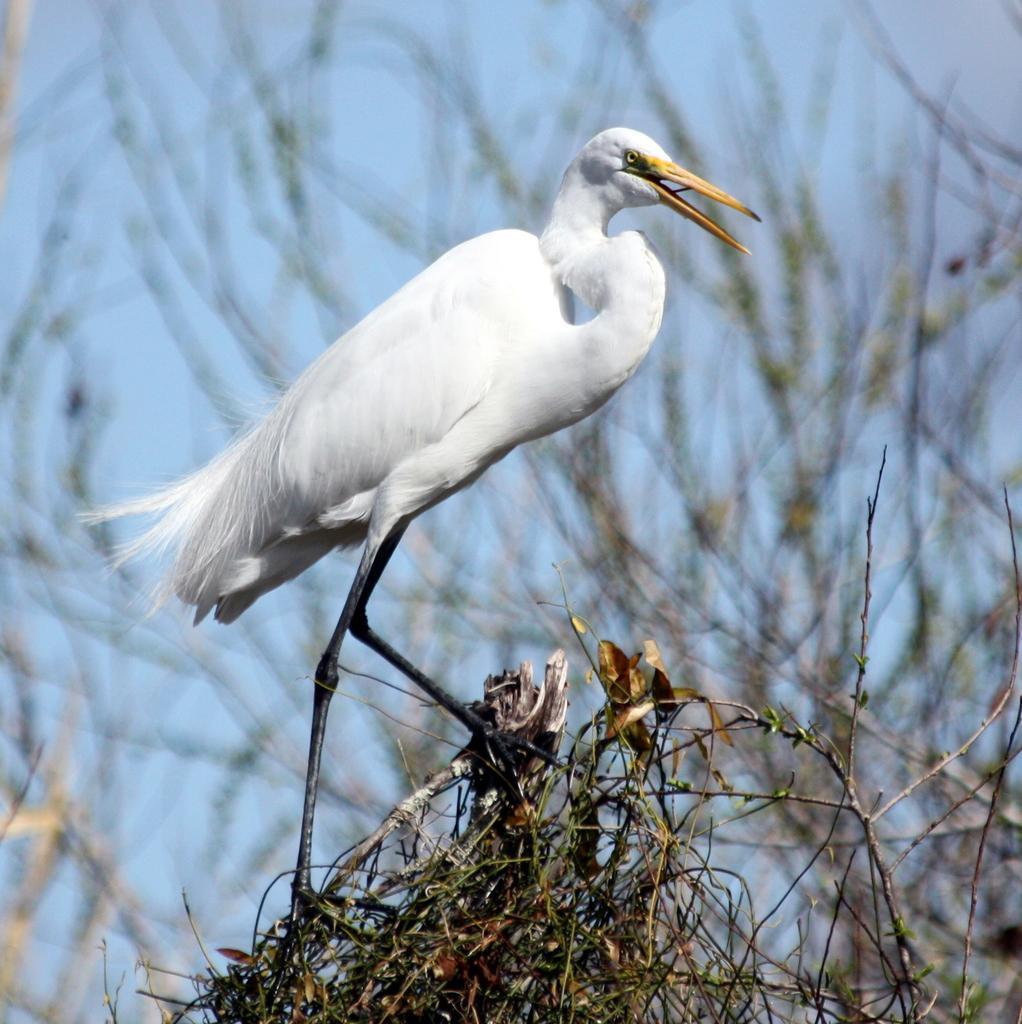Can you describe this image briefly? This is a bird standing. I think these are the stems. The background looks blurry. 